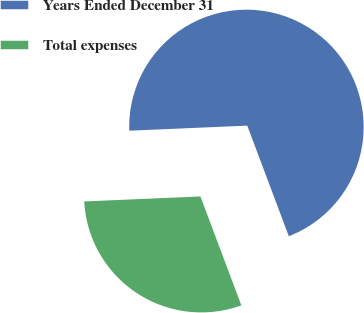Convert chart. <chart><loc_0><loc_0><loc_500><loc_500><pie_chart><fcel>Years Ended December 31<fcel>Total expenses<nl><fcel>69.96%<fcel>30.04%<nl></chart> 